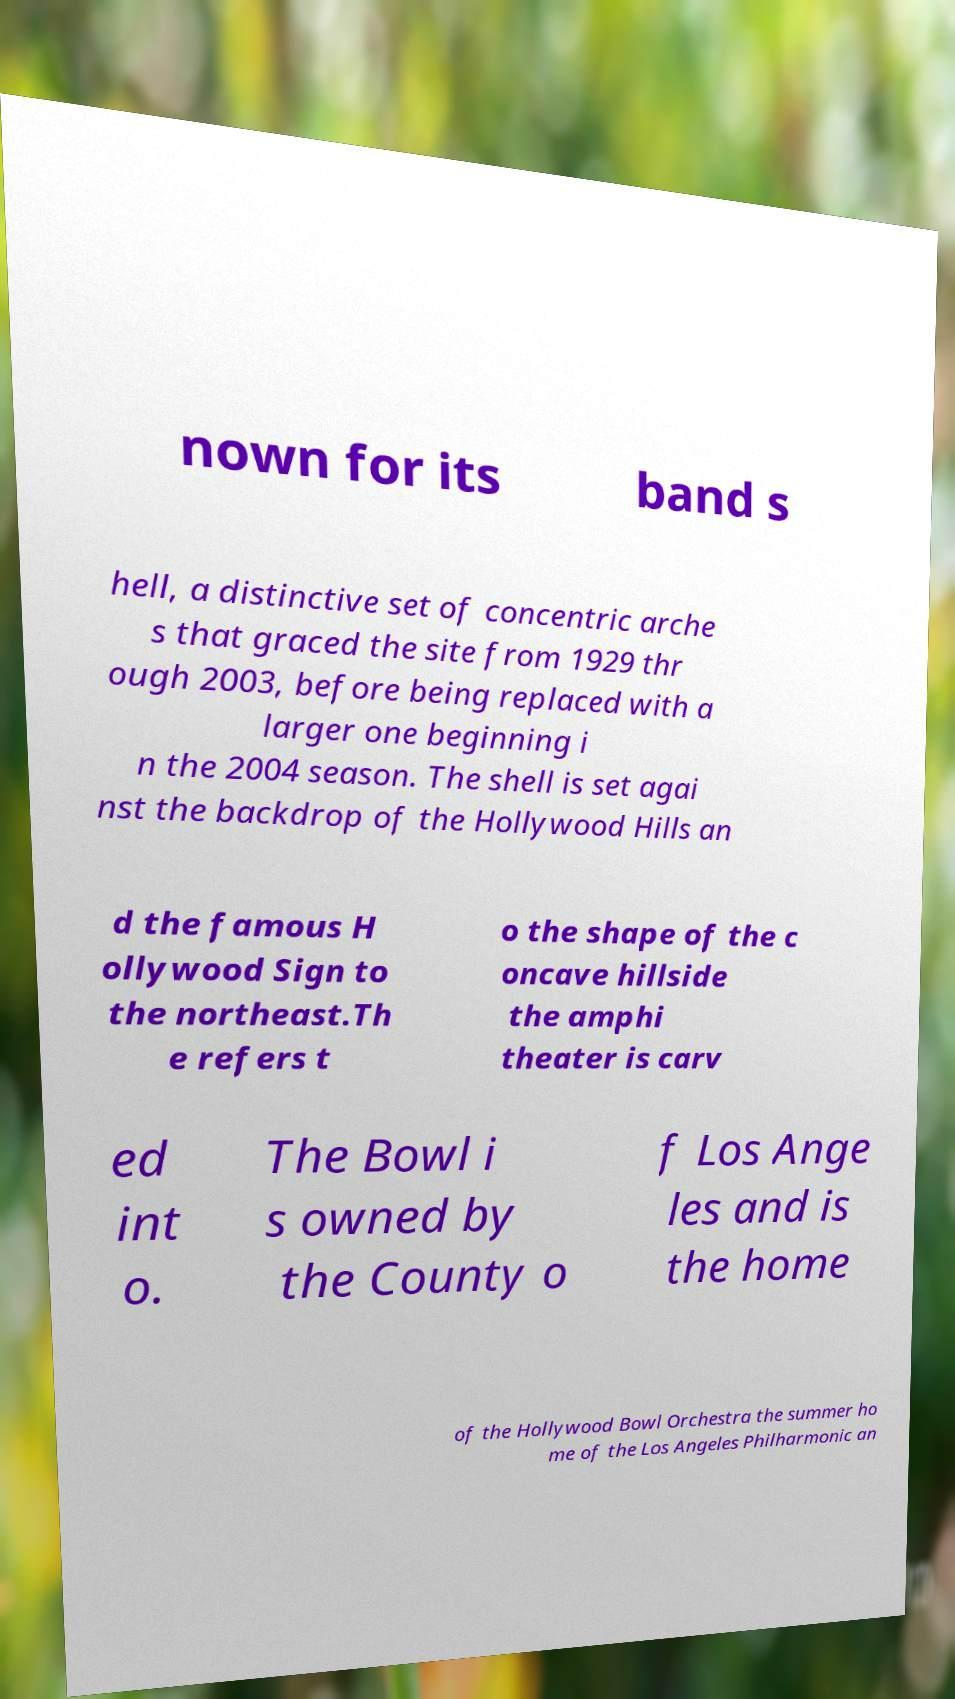For documentation purposes, I need the text within this image transcribed. Could you provide that? nown for its band s hell, a distinctive set of concentric arche s that graced the site from 1929 thr ough 2003, before being replaced with a larger one beginning i n the 2004 season. The shell is set agai nst the backdrop of the Hollywood Hills an d the famous H ollywood Sign to the northeast.Th e refers t o the shape of the c oncave hillside the amphi theater is carv ed int o. The Bowl i s owned by the County o f Los Ange les and is the home of the Hollywood Bowl Orchestra the summer ho me of the Los Angeles Philharmonic an 